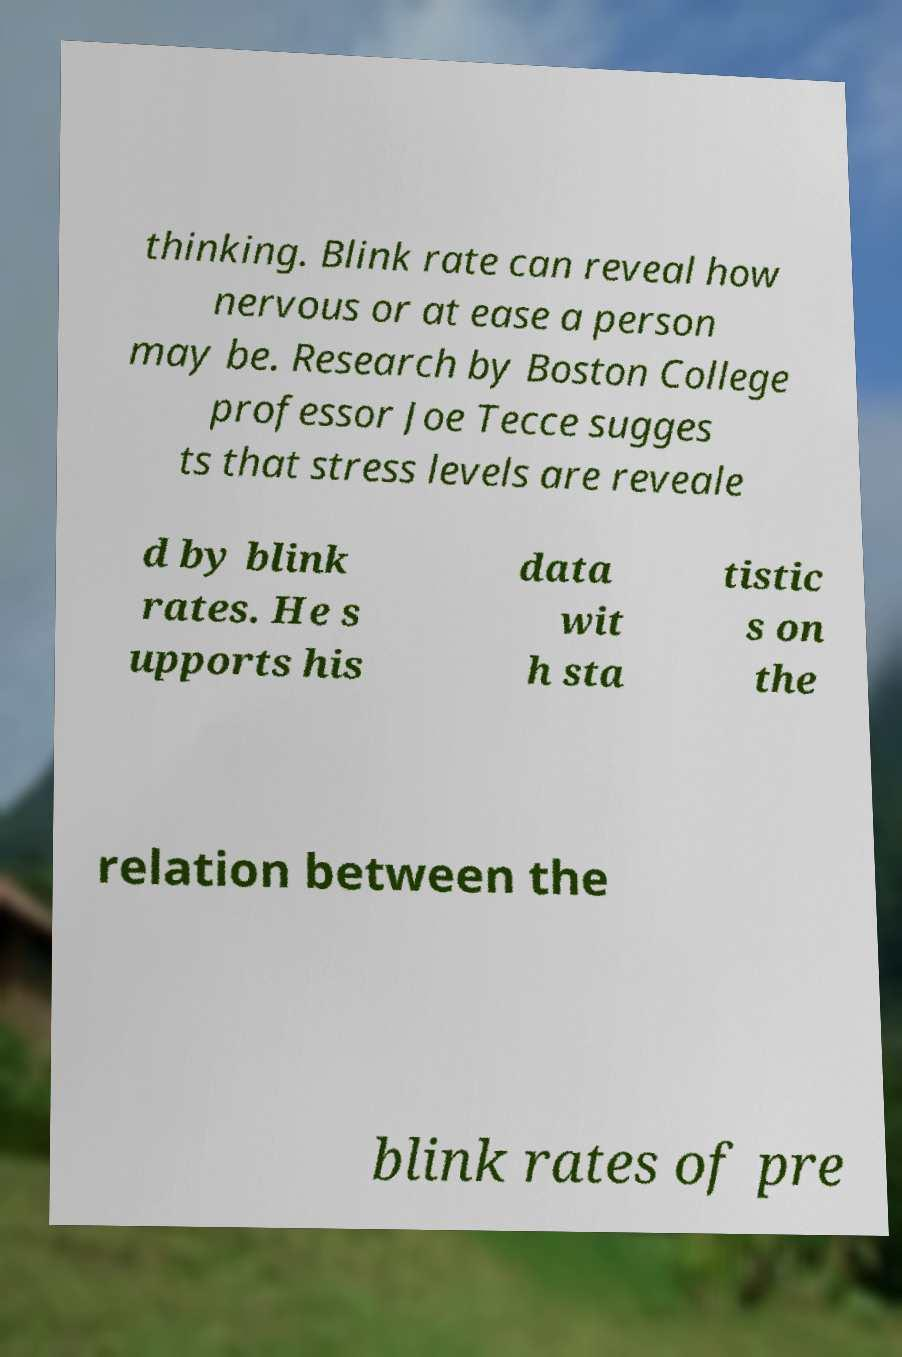Please identify and transcribe the text found in this image. thinking. Blink rate can reveal how nervous or at ease a person may be. Research by Boston College professor Joe Tecce sugges ts that stress levels are reveale d by blink rates. He s upports his data wit h sta tistic s on the relation between the blink rates of pre 